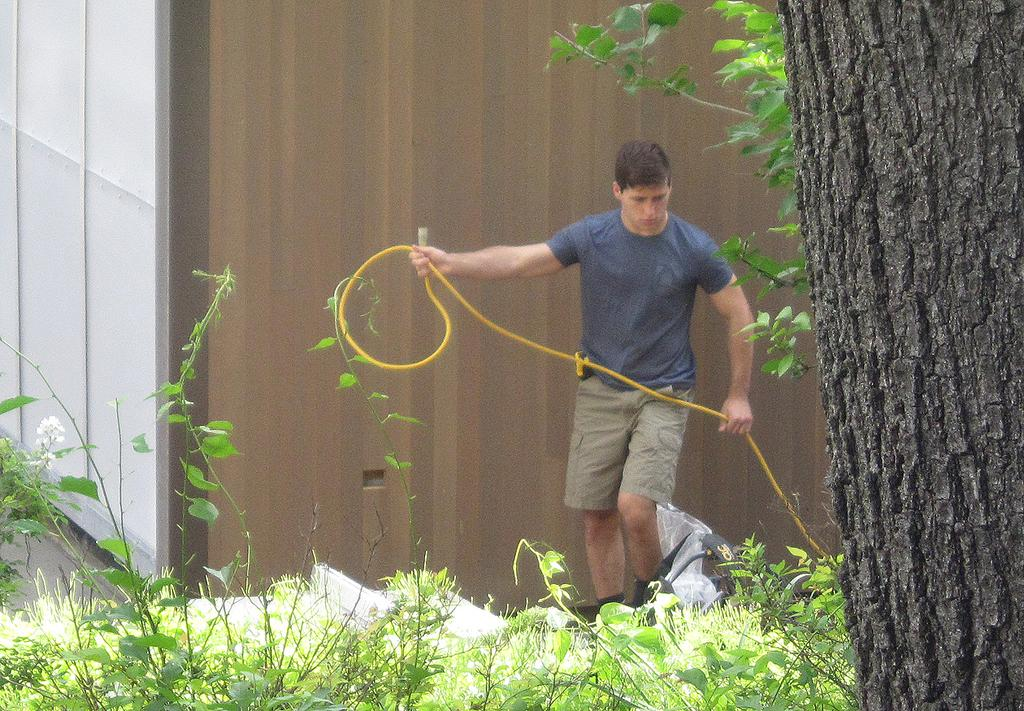What is the main subject of the image? There is a man standing in the center of the image. What is the man holding in the image? The man is holding a pipe. What type of vegetation is present at the bottom of the image? There is grass and plants at the bottom of the image. What can be seen on the right side of the image? There is a tree on the right side of the image. What is visible in the background of the image? There is a wall in the background of the image. Can you tell me how many snails are crawling on the man's shoes in the image? There are no snails visible on the man's shoes in the image. What type of drink is the man holding in the image? The man is holding a pipe, not a drink, in the image. 